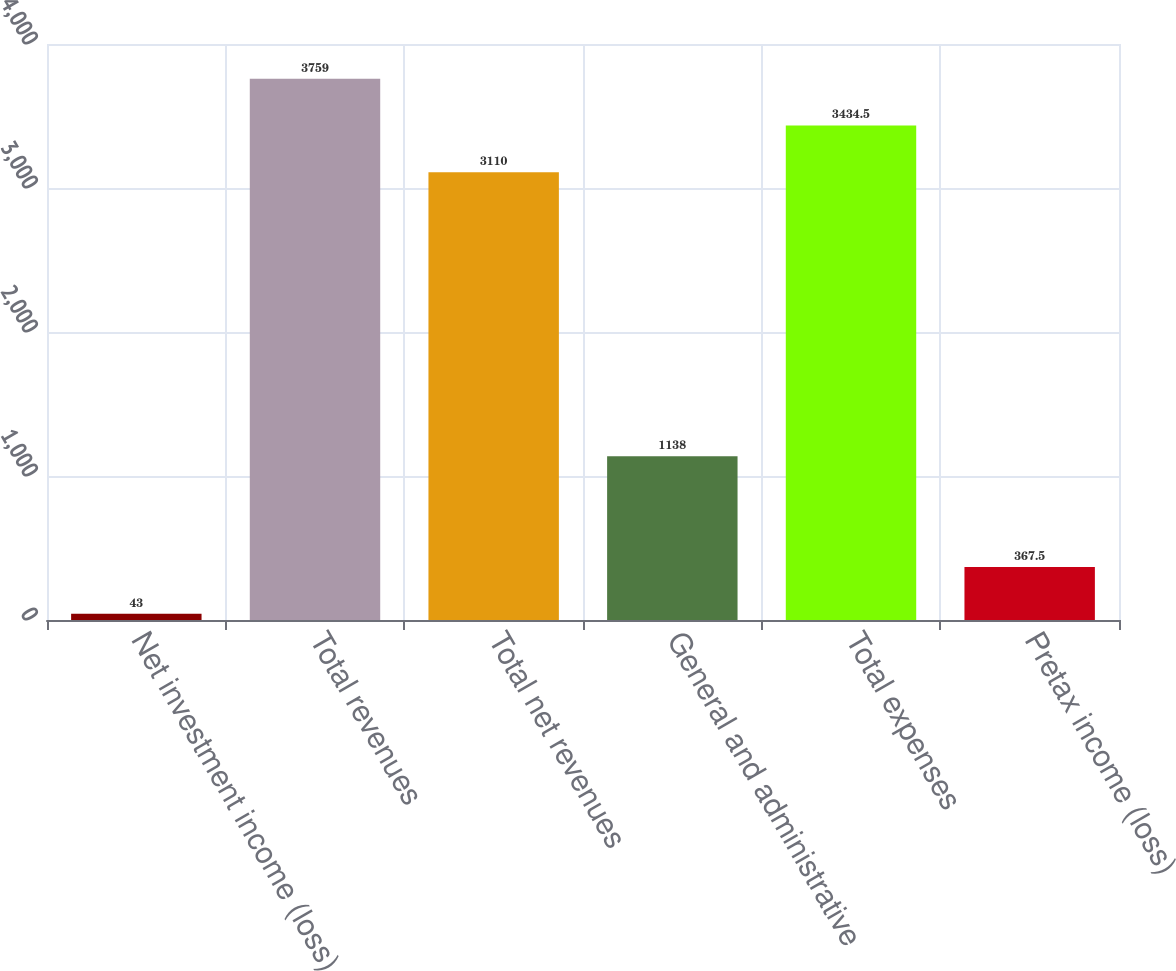<chart> <loc_0><loc_0><loc_500><loc_500><bar_chart><fcel>Net investment income (loss)<fcel>Total revenues<fcel>Total net revenues<fcel>General and administrative<fcel>Total expenses<fcel>Pretax income (loss)<nl><fcel>43<fcel>3759<fcel>3110<fcel>1138<fcel>3434.5<fcel>367.5<nl></chart> 